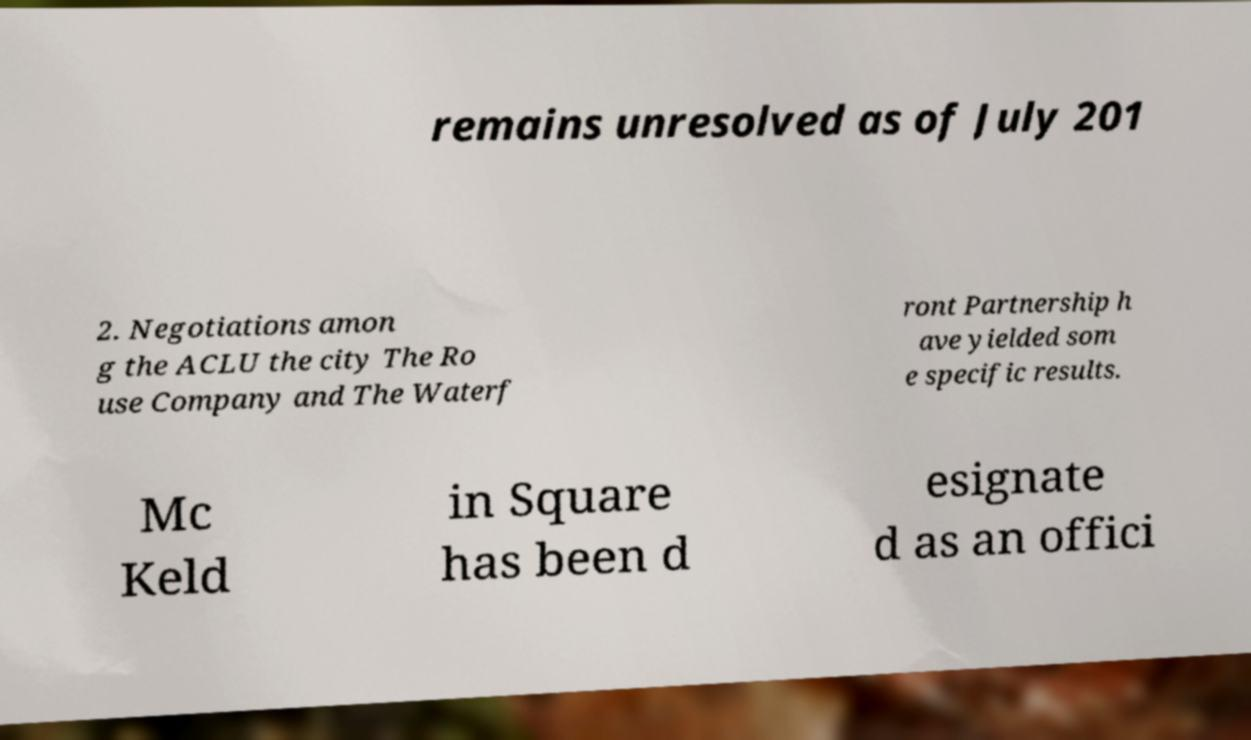Can you accurately transcribe the text from the provided image for me? remains unresolved as of July 201 2. Negotiations amon g the ACLU the city The Ro use Company and The Waterf ront Partnership h ave yielded som e specific results. Mc Keld in Square has been d esignate d as an offici 